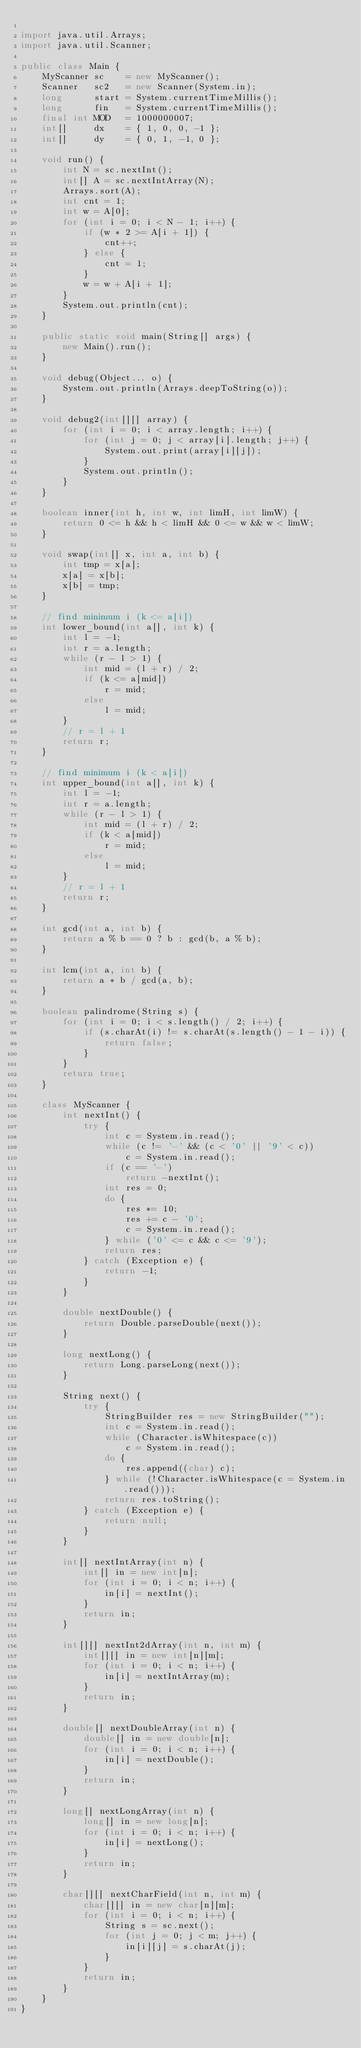Convert code to text. <code><loc_0><loc_0><loc_500><loc_500><_Java_>
import java.util.Arrays;
import java.util.Scanner;

public class Main {
    MyScanner sc    = new MyScanner();
    Scanner   sc2   = new Scanner(System.in);
    long      start = System.currentTimeMillis();
    long      fin   = System.currentTimeMillis();
    final int MOD   = 1000000007;
    int[]     dx    = { 1, 0, 0, -1 };
    int[]     dy    = { 0, 1, -1, 0 };

    void run() {
        int N = sc.nextInt();
        int[] A = sc.nextIntArray(N);
        Arrays.sort(A);
        int cnt = 1;
        int w = A[0];
        for (int i = 0; i < N - 1; i++) {
            if (w * 2 >= A[i + 1]) {
                cnt++;
            } else {
                cnt = 1;
            }
            w = w + A[i + 1];
        }
        System.out.println(cnt);
    }

    public static void main(String[] args) {
        new Main().run();
    }

    void debug(Object... o) {
        System.out.println(Arrays.deepToString(o));
    }

    void debug2(int[][] array) {
        for (int i = 0; i < array.length; i++) {
            for (int j = 0; j < array[i].length; j++) {
                System.out.print(array[i][j]);
            }
            System.out.println();
        }
    }

    boolean inner(int h, int w, int limH, int limW) {
        return 0 <= h && h < limH && 0 <= w && w < limW;
    }

    void swap(int[] x, int a, int b) {
        int tmp = x[a];
        x[a] = x[b];
        x[b] = tmp;
    }

    // find minimum i (k <= a[i])
    int lower_bound(int a[], int k) {
        int l = -1;
        int r = a.length;
        while (r - l > 1) {
            int mid = (l + r) / 2;
            if (k <= a[mid])
                r = mid;
            else
                l = mid;
        }
        // r = l + 1
        return r;
    }

    // find minimum i (k < a[i])
    int upper_bound(int a[], int k) {
        int l = -1;
        int r = a.length;
        while (r - l > 1) {
            int mid = (l + r) / 2;
            if (k < a[mid])
                r = mid;
            else
                l = mid;
        }
        // r = l + 1
        return r;
    }

    int gcd(int a, int b) {
        return a % b == 0 ? b : gcd(b, a % b);
    }

    int lcm(int a, int b) {
        return a * b / gcd(a, b);
    }

    boolean palindrome(String s) {
        for (int i = 0; i < s.length() / 2; i++) {
            if (s.charAt(i) != s.charAt(s.length() - 1 - i)) {
                return false;
            }
        }
        return true;
    }

    class MyScanner {
        int nextInt() {
            try {
                int c = System.in.read();
                while (c != '-' && (c < '0' || '9' < c))
                    c = System.in.read();
                if (c == '-')
                    return -nextInt();
                int res = 0;
                do {
                    res *= 10;
                    res += c - '0';
                    c = System.in.read();
                } while ('0' <= c && c <= '9');
                return res;
            } catch (Exception e) {
                return -1;
            }
        }

        double nextDouble() {
            return Double.parseDouble(next());
        }

        long nextLong() {
            return Long.parseLong(next());
        }

        String next() {
            try {
                StringBuilder res = new StringBuilder("");
                int c = System.in.read();
                while (Character.isWhitespace(c))
                    c = System.in.read();
                do {
                    res.append((char) c);
                } while (!Character.isWhitespace(c = System.in.read()));
                return res.toString();
            } catch (Exception e) {
                return null;
            }
        }

        int[] nextIntArray(int n) {
            int[] in = new int[n];
            for (int i = 0; i < n; i++) {
                in[i] = nextInt();
            }
            return in;
        }

        int[][] nextInt2dArray(int n, int m) {
            int[][] in = new int[n][m];
            for (int i = 0; i < n; i++) {
                in[i] = nextIntArray(m);
            }
            return in;
        }

        double[] nextDoubleArray(int n) {
            double[] in = new double[n];
            for (int i = 0; i < n; i++) {
                in[i] = nextDouble();
            }
            return in;
        }

        long[] nextLongArray(int n) {
            long[] in = new long[n];
            for (int i = 0; i < n; i++) {
                in[i] = nextLong();
            }
            return in;
        }

        char[][] nextCharField(int n, int m) {
            char[][] in = new char[n][m];
            for (int i = 0; i < n; i++) {
                String s = sc.next();
                for (int j = 0; j < m; j++) {
                    in[i][j] = s.charAt(j);
                }
            }
            return in;
        }
    }
}</code> 